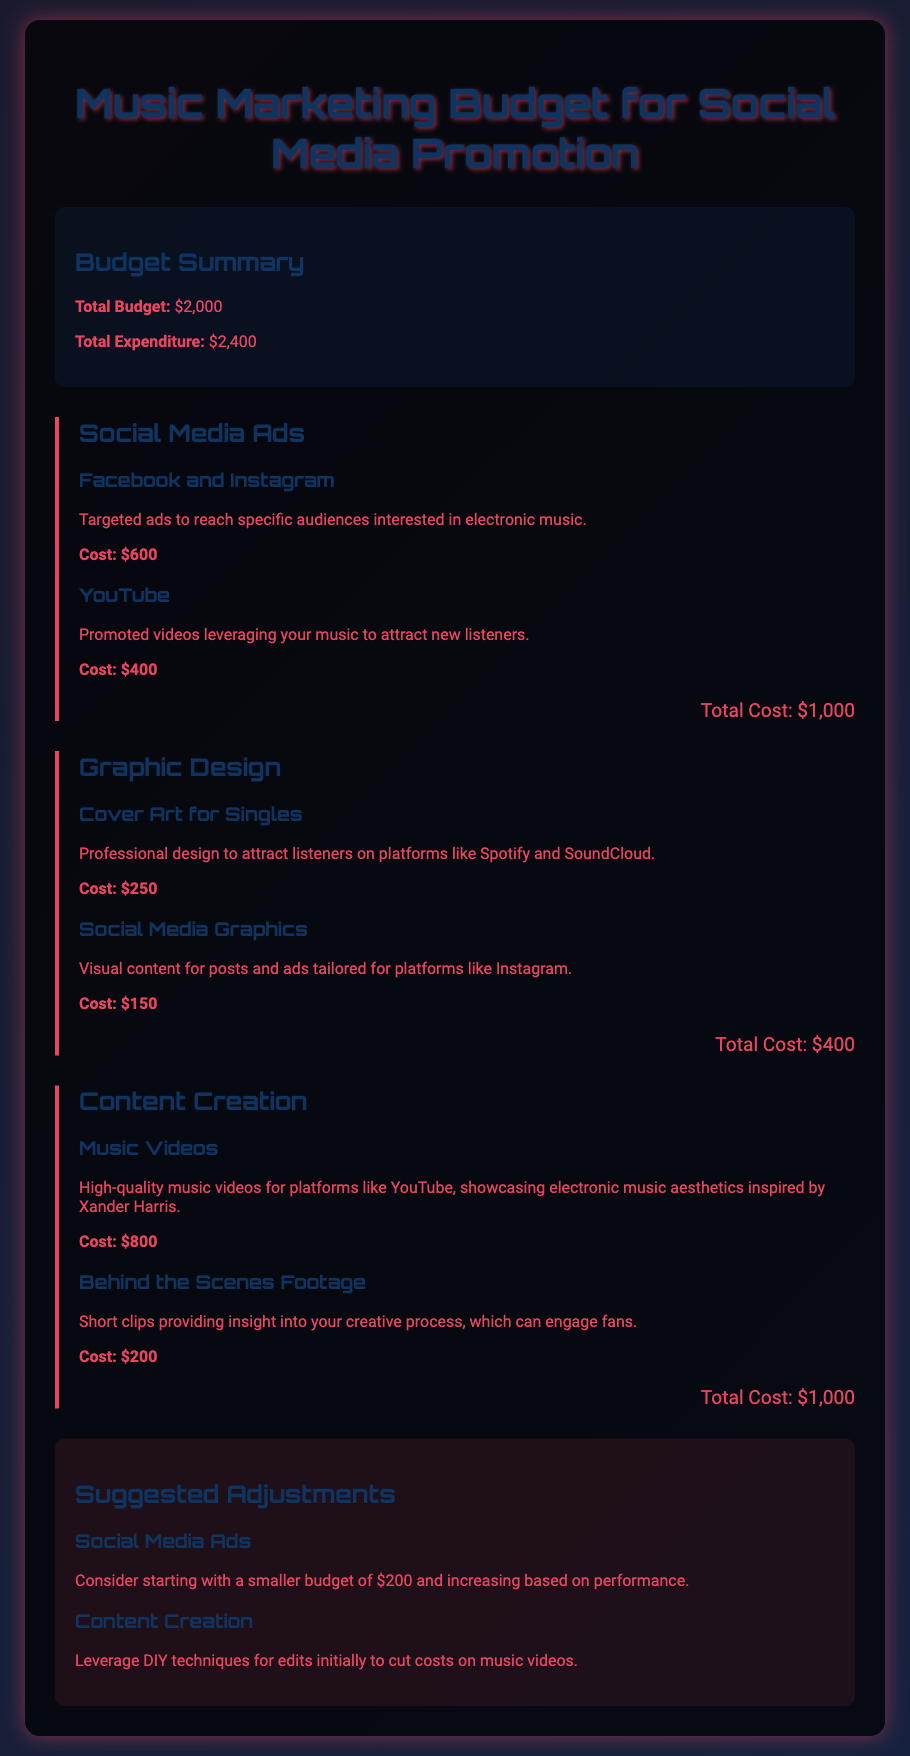What is the total budget? The total budget is specified clearly at the beginning of the document as $2,000.
Answer: $2,000 What is the cost for Facebook and Instagram ads? The document outlines that Facebook and Instagram ads cost $600.
Answer: $600 How much is allocated for music videos? The section on content creation mentions that music videos cost $800.
Answer: $800 What is the total expenditure? The total expenditure is highlighted in the budget summary as $2,400.
Answer: $2,400 How much is spent on graphic design? The total cost for graphic design, which includes cover art and social media graphics, is $400.
Answer: $400 What suggested adjustment is made for social media ads? The document suggests starting with a smaller budget of $200 for social media ads.
Answer: $200 What is the cost for behind the scenes footage? The cost for behind the scenes footage is listed as $200.
Answer: $200 What is the total cost for content creation? The total cost for content creation, which includes music videos and behind the scenes footage, is $1,000.
Answer: $1,000 What specific visual content is suggested for Instagram? The document suggests social media graphics as visual content for Instagram.
Answer: Social Media Graphics 